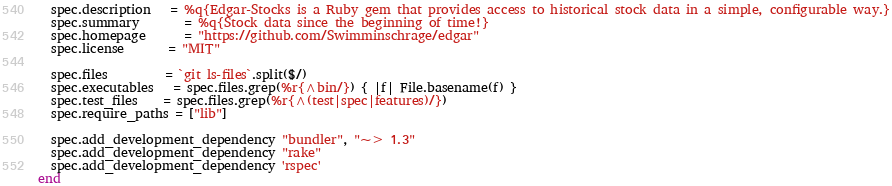<code> <loc_0><loc_0><loc_500><loc_500><_Ruby_>  spec.description   = %q{Edgar-Stocks is a Ruby gem that provides access to historical stock data in a simple, configurable way.}
  spec.summary       = %q{Stock data since the beginning of time!}
  spec.homepage      = "https://github.com/Swimminschrage/edgar"
  spec.license       = "MIT"

  spec.files         = `git ls-files`.split($/)
  spec.executables   = spec.files.grep(%r{^bin/}) { |f| File.basename(f) }
  spec.test_files    = spec.files.grep(%r{^(test|spec|features)/})
  spec.require_paths = ["lib"]

  spec.add_development_dependency "bundler", "~> 1.3"
  spec.add_development_dependency "rake"
  spec.add_development_dependency 'rspec'
end
</code> 